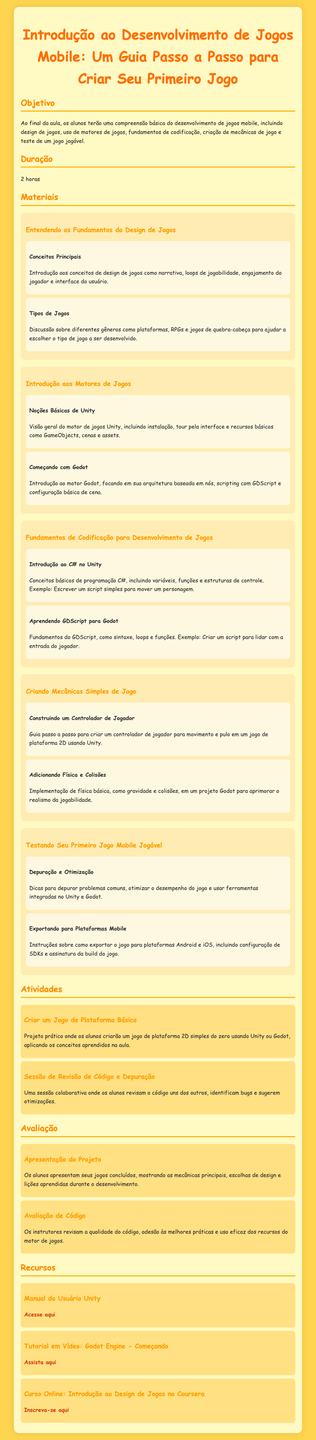qual é o objetivo da aula? O objetivo da aula é uma compreensão básica do desenvolvimento de jogos mobile, incluindo design, uso de motores, codificação, criação de mecânicas e teste de um jogo jogável.
Answer: compreensão básica do desenvolvimento de jogos mobile qual é a duração da aula? A duração da aula é mencionada claramente no documento, que é de 2 horas.
Answer: 2 horas quais motores de jogos são introduzidos? O documento menciona dois motores de jogos específicos que são apresentados na aula: Unity e Godot.
Answer: Unity e Godot o que é ensinado na seção "Fundamentos de Codificação"? A seção "Fundamentos de Codificação" é focada em apresentar a programação C# e GDScript, incluindo variáveis, funções, e estruturas de controle.
Answer: programação C# e GDScript qual é a atividade prática proposta? A atividade prática envolve criar um jogo de plataforma 2D simples do zero, aplicando os conceitos aprendidos na aula.
Answer: criar um jogo de plataforma 2D simples que tipo de avaliação é realizada após o projeto? Após o projeto, os alunos apresentam seus jogos concluídos como um tipo de avaliação.
Answer: apresentação do projeto quais são os tipos de jogos discutidos? O documento menciona tipos de jogos como plataformas, RPGs e jogos de quebra-cabeça na discussão sobre gêneros.
Answer: plataformas, RPGs e jogos de quebra-cabeça qual é o recurso para aprender sobre o Unity? O recurso apresentado para aprender sobre o Unity é o "Manual do Usuário Unity".
Answer: Manual do Usuário Unity quantas atividades práticas são listadas? Existem duas atividades práticas listadas que os alunos devem realizar durante a aula.
Answer: duas atividades práticas 